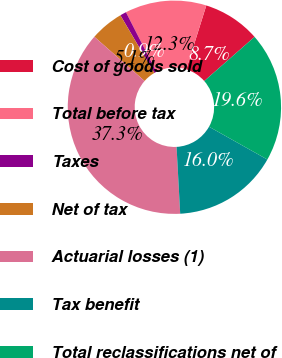<chart> <loc_0><loc_0><loc_500><loc_500><pie_chart><fcel>Cost of goods sold<fcel>Total before tax<fcel>Taxes<fcel>Net of tax<fcel>Actuarial losses (1)<fcel>Tax benefit<fcel>Total reclassifications net of<nl><fcel>8.7%<fcel>12.34%<fcel>0.95%<fcel>5.06%<fcel>37.35%<fcel>15.98%<fcel>19.62%<nl></chart> 